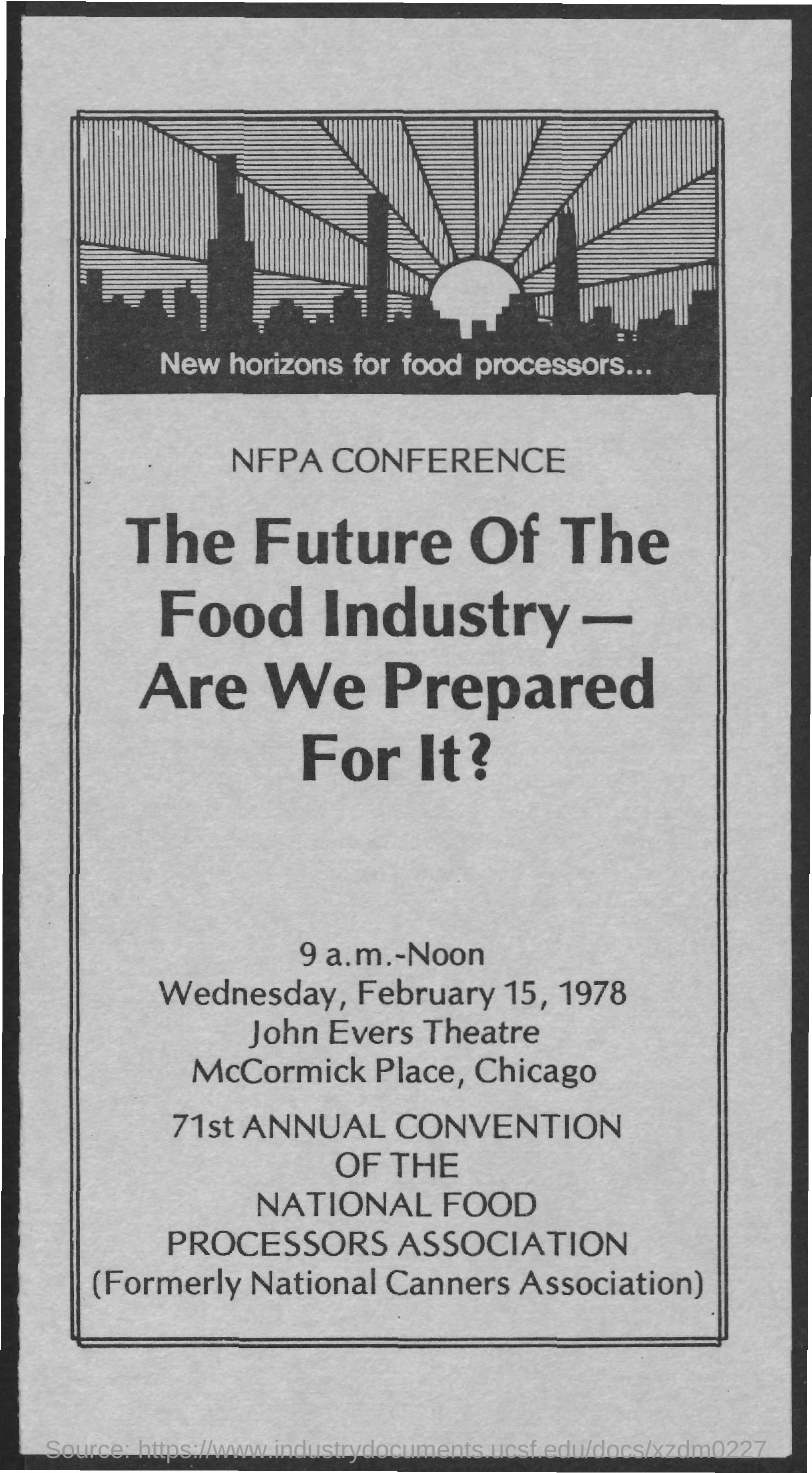Draw attention to some important aspects in this diagram. The John Evers Theatre is the name of the theatre. On Wednesday, February 15, 1978, the date mentioned, was on that day. 